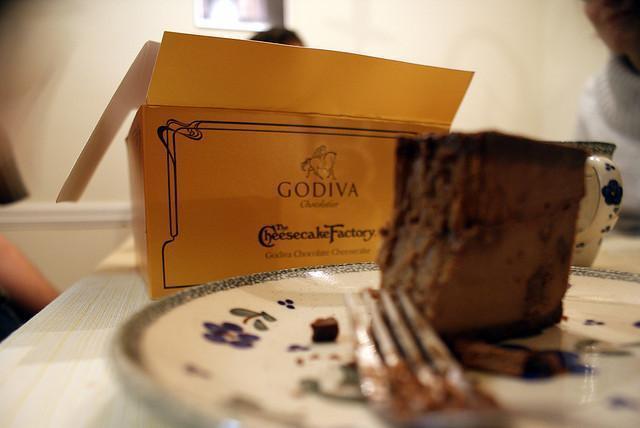How many dining tables are in the photo?
Give a very brief answer. 1. How many people are there?
Give a very brief answer. 2. How many zebra near from tree?
Give a very brief answer. 0. 